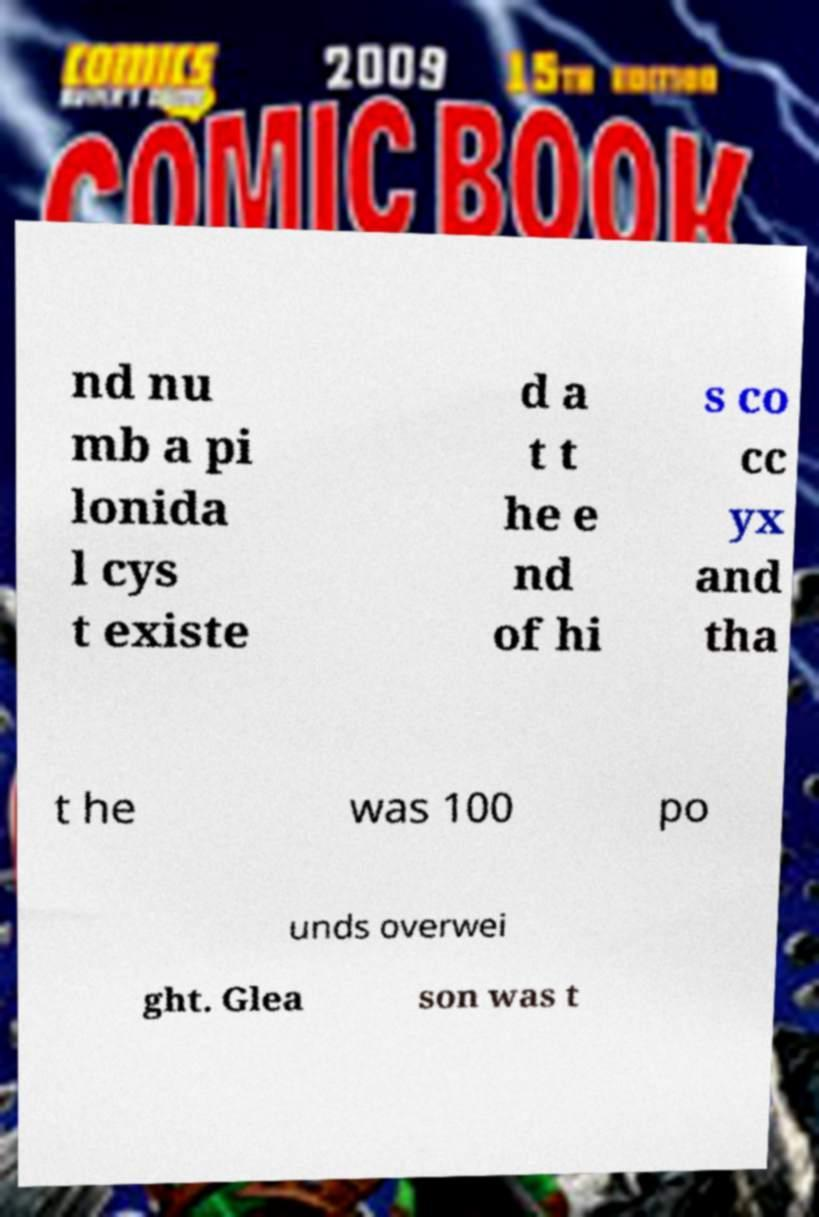Please read and relay the text visible in this image. What does it say? nd nu mb a pi lonida l cys t existe d a t t he e nd of hi s co cc yx and tha t he was 100 po unds overwei ght. Glea son was t 